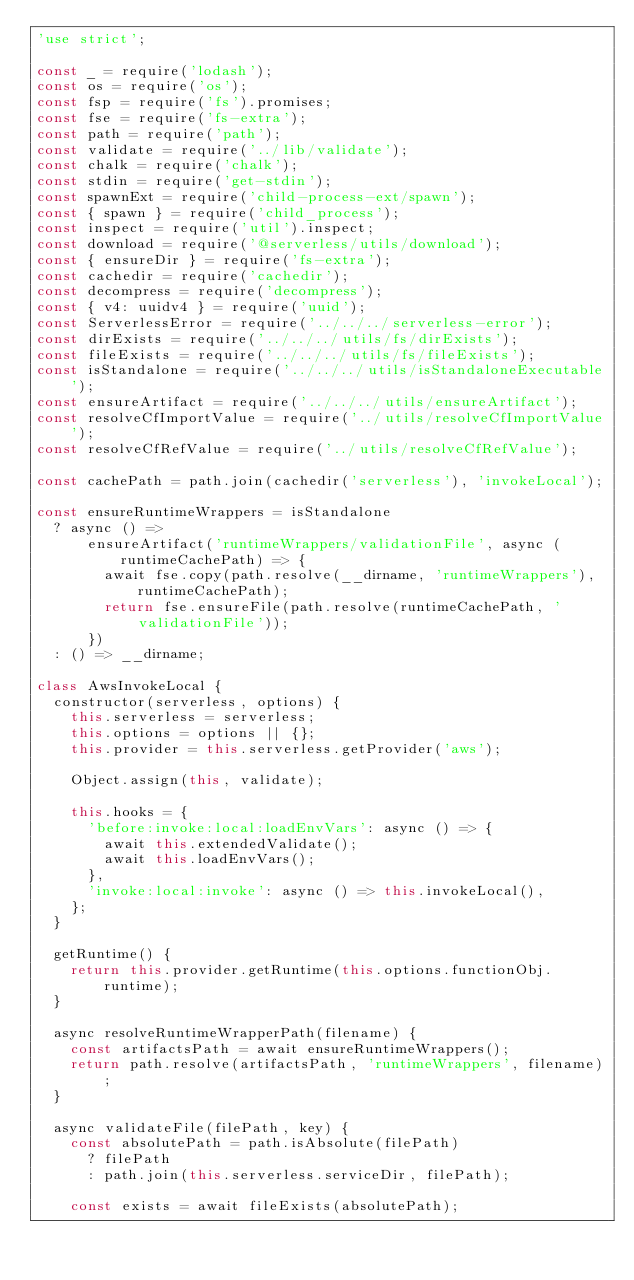Convert code to text. <code><loc_0><loc_0><loc_500><loc_500><_JavaScript_>'use strict';

const _ = require('lodash');
const os = require('os');
const fsp = require('fs').promises;
const fse = require('fs-extra');
const path = require('path');
const validate = require('../lib/validate');
const chalk = require('chalk');
const stdin = require('get-stdin');
const spawnExt = require('child-process-ext/spawn');
const { spawn } = require('child_process');
const inspect = require('util').inspect;
const download = require('@serverless/utils/download');
const { ensureDir } = require('fs-extra');
const cachedir = require('cachedir');
const decompress = require('decompress');
const { v4: uuidv4 } = require('uuid');
const ServerlessError = require('../../../serverless-error');
const dirExists = require('../../../utils/fs/dirExists');
const fileExists = require('../../../utils/fs/fileExists');
const isStandalone = require('../../../utils/isStandaloneExecutable');
const ensureArtifact = require('../../../utils/ensureArtifact');
const resolveCfImportValue = require('../utils/resolveCfImportValue');
const resolveCfRefValue = require('../utils/resolveCfRefValue');

const cachePath = path.join(cachedir('serverless'), 'invokeLocal');

const ensureRuntimeWrappers = isStandalone
  ? async () =>
      ensureArtifact('runtimeWrappers/validationFile', async (runtimeCachePath) => {
        await fse.copy(path.resolve(__dirname, 'runtimeWrappers'), runtimeCachePath);
        return fse.ensureFile(path.resolve(runtimeCachePath, 'validationFile'));
      })
  : () => __dirname;

class AwsInvokeLocal {
  constructor(serverless, options) {
    this.serverless = serverless;
    this.options = options || {};
    this.provider = this.serverless.getProvider('aws');

    Object.assign(this, validate);

    this.hooks = {
      'before:invoke:local:loadEnvVars': async () => {
        await this.extendedValidate();
        await this.loadEnvVars();
      },
      'invoke:local:invoke': async () => this.invokeLocal(),
    };
  }

  getRuntime() {
    return this.provider.getRuntime(this.options.functionObj.runtime);
  }

  async resolveRuntimeWrapperPath(filename) {
    const artifactsPath = await ensureRuntimeWrappers();
    return path.resolve(artifactsPath, 'runtimeWrappers', filename);
  }

  async validateFile(filePath, key) {
    const absolutePath = path.isAbsolute(filePath)
      ? filePath
      : path.join(this.serverless.serviceDir, filePath);

    const exists = await fileExists(absolutePath);
</code> 